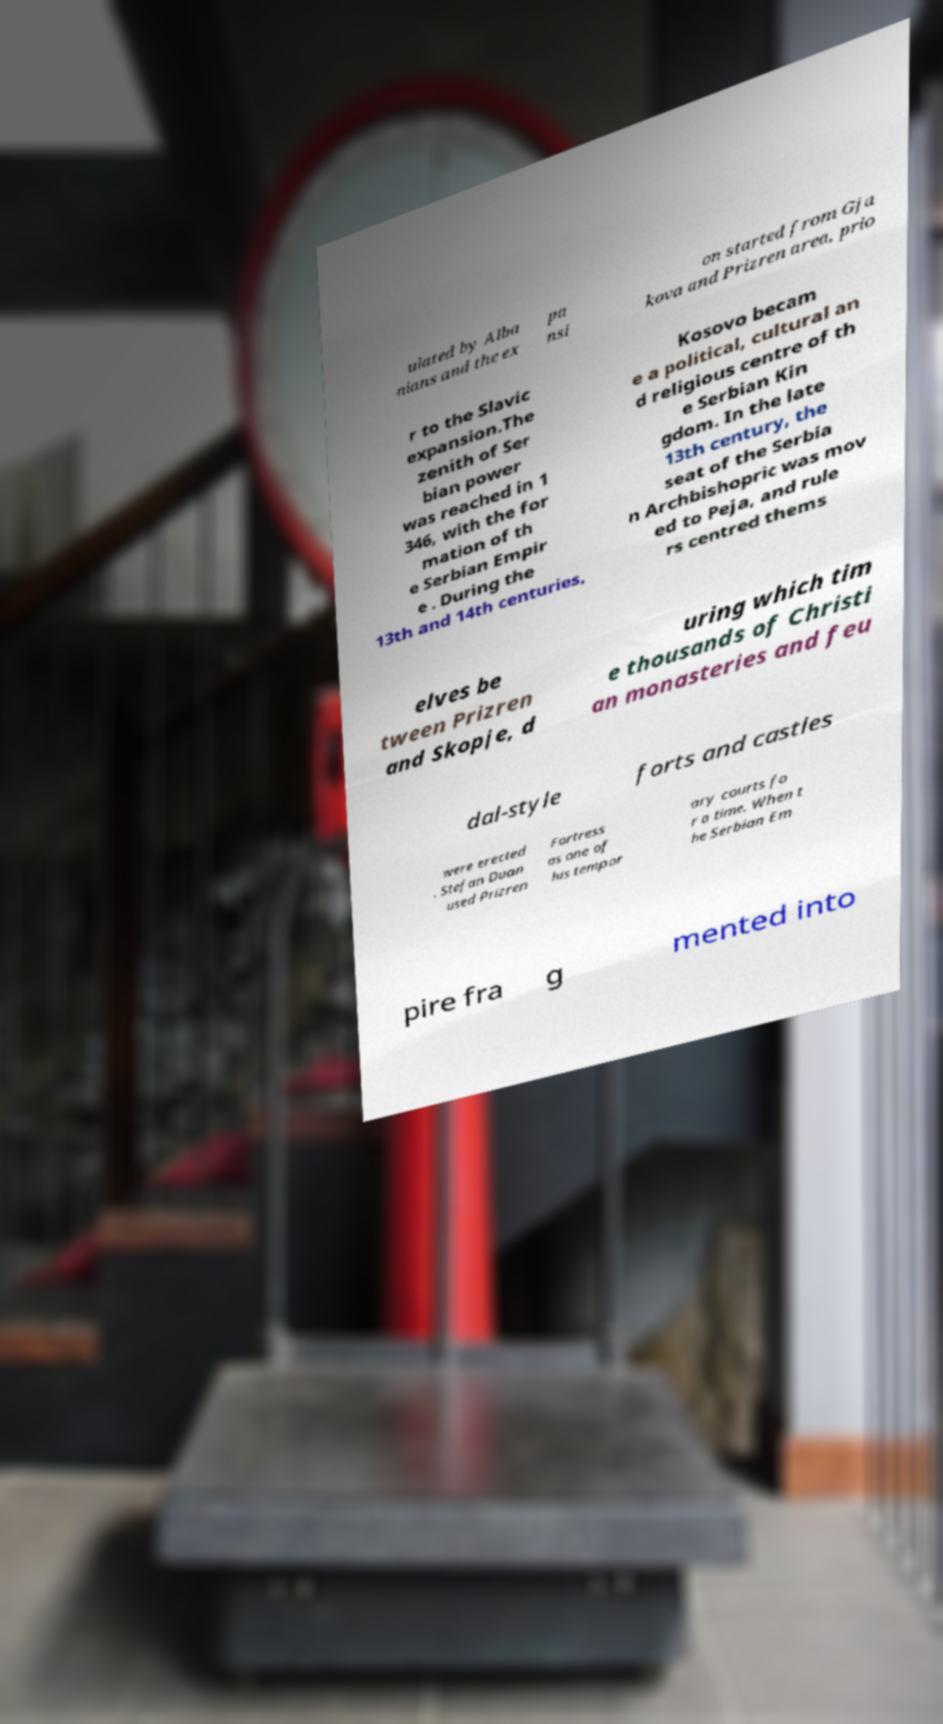Please identify and transcribe the text found in this image. ulated by Alba nians and the ex pa nsi on started from Gja kova and Prizren area, prio r to the Slavic expansion.The zenith of Ser bian power was reached in 1 346, with the for mation of th e Serbian Empir e . During the 13th and 14th centuries, Kosovo becam e a political, cultural an d religious centre of th e Serbian Kin gdom. In the late 13th century, the seat of the Serbia n Archbishopric was mov ed to Peja, and rule rs centred thems elves be tween Prizren and Skopje, d uring which tim e thousands of Christi an monasteries and feu dal-style forts and castles were erected . Stefan Duan used Prizren Fortress as one of his tempor ary courts fo r a time. When t he Serbian Em pire fra g mented into 